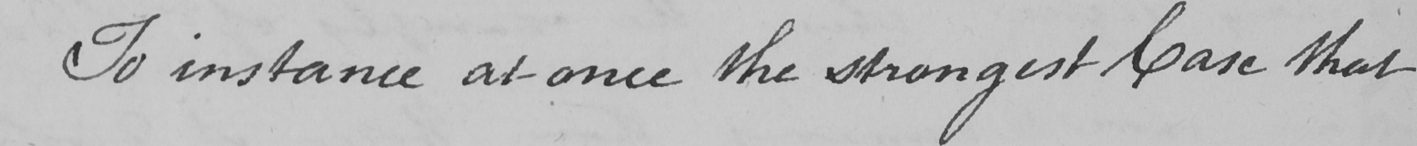Please provide the text content of this handwritten line. To instance at once the strongest Case that 